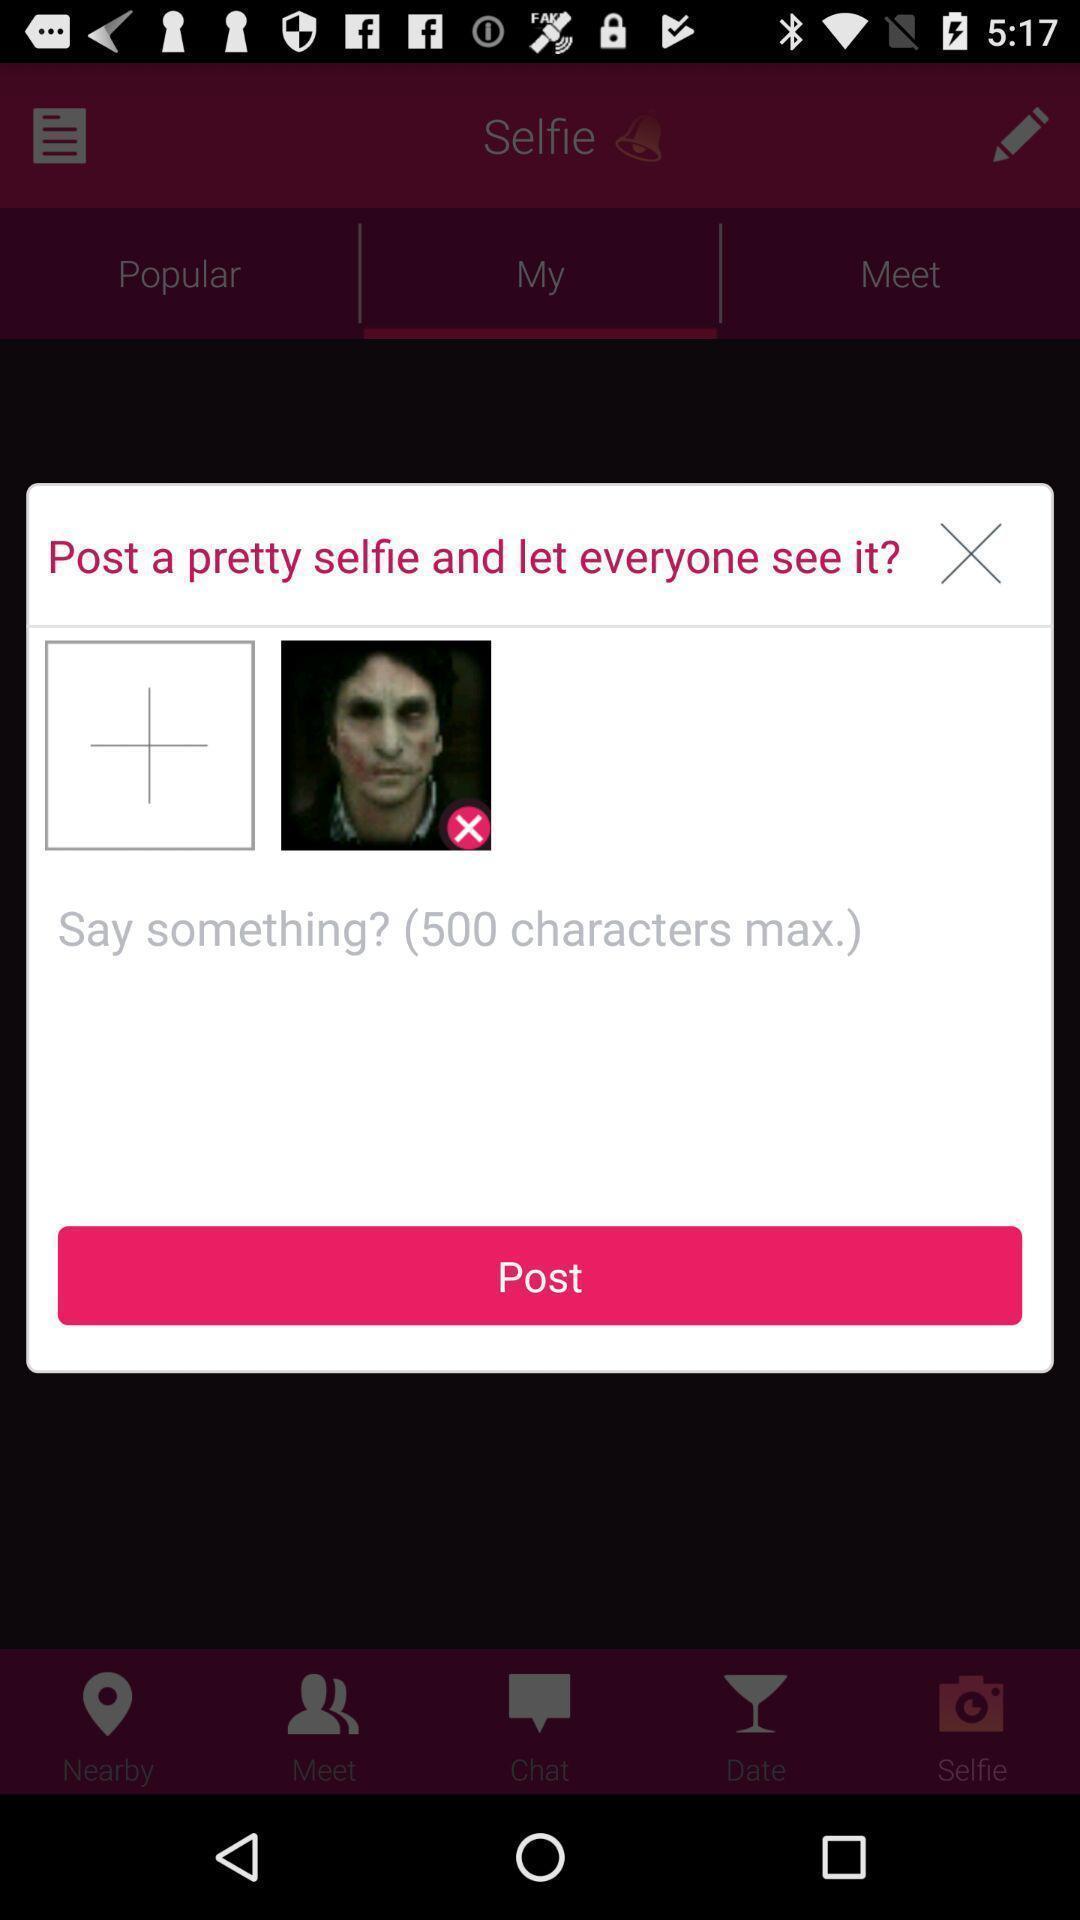Tell me what you see in this picture. Popup requesting to add image or say something to post. 